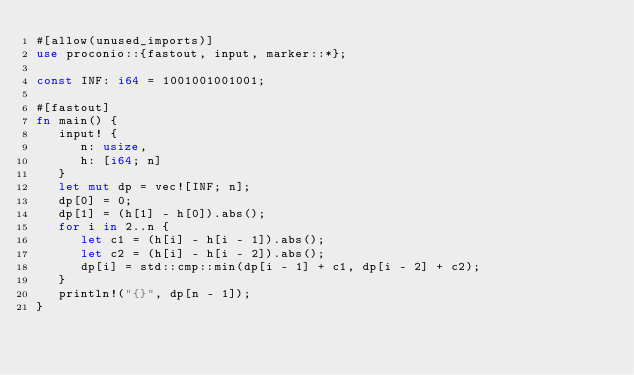<code> <loc_0><loc_0><loc_500><loc_500><_Rust_>#[allow(unused_imports)]
use proconio::{fastout, input, marker::*};

const INF: i64 = 1001001001001;

#[fastout]
fn main() {
   input! {
      n: usize,
      h: [i64; n]
   }
   let mut dp = vec![INF; n];
   dp[0] = 0;
   dp[1] = (h[1] - h[0]).abs();
   for i in 2..n {
      let c1 = (h[i] - h[i - 1]).abs();
      let c2 = (h[i] - h[i - 2]).abs();
      dp[i] = std::cmp::min(dp[i - 1] + c1, dp[i - 2] + c2);
   }
   println!("{}", dp[n - 1]);
}
</code> 